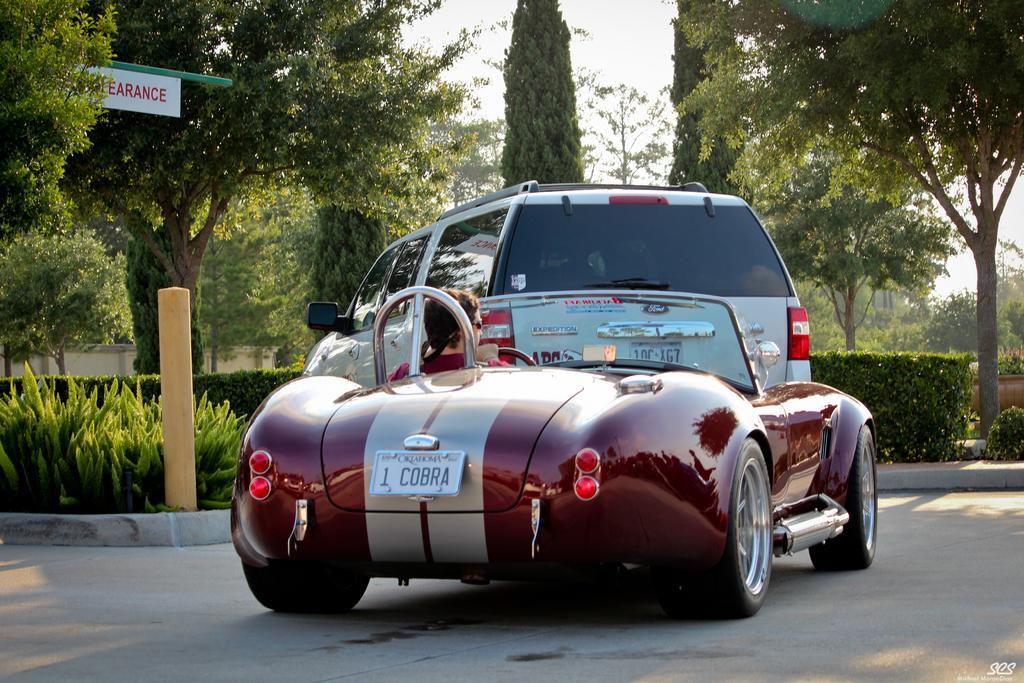In one or two sentences, can you explain what this image depicts? In the image there is a car parked in front of a garden and behind the car and another red car is moving on the path and there is an entrance board in front of the garden,in the garden there are plenty of trees and beautiful greenery. 